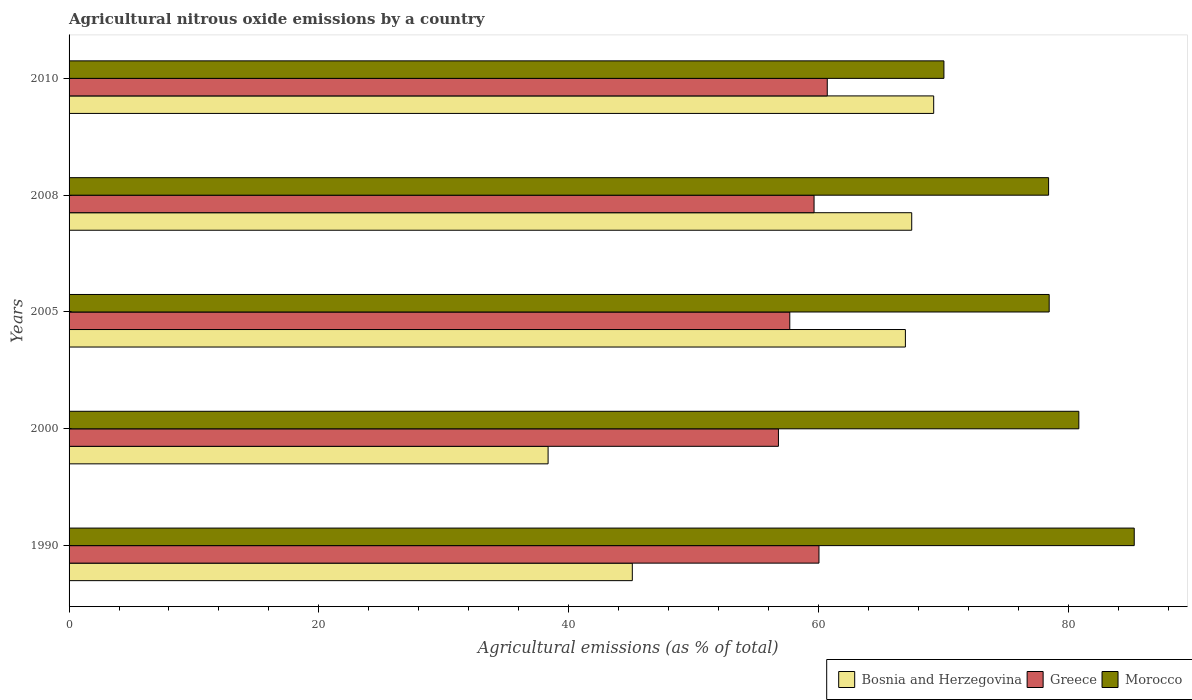How many different coloured bars are there?
Give a very brief answer. 3. Are the number of bars on each tick of the Y-axis equal?
Your response must be concise. Yes. How many bars are there on the 2nd tick from the bottom?
Your answer should be compact. 3. What is the label of the 5th group of bars from the top?
Your answer should be very brief. 1990. In how many cases, is the number of bars for a given year not equal to the number of legend labels?
Your response must be concise. 0. What is the amount of agricultural nitrous oxide emitted in Greece in 2008?
Your answer should be very brief. 59.65. Across all years, what is the maximum amount of agricultural nitrous oxide emitted in Morocco?
Make the answer very short. 85.29. Across all years, what is the minimum amount of agricultural nitrous oxide emitted in Morocco?
Offer a very short reply. 70.05. What is the total amount of agricultural nitrous oxide emitted in Bosnia and Herzegovina in the graph?
Your answer should be compact. 287.13. What is the difference between the amount of agricultural nitrous oxide emitted in Bosnia and Herzegovina in 2000 and that in 2010?
Provide a short and direct response. -30.88. What is the difference between the amount of agricultural nitrous oxide emitted in Bosnia and Herzegovina in 1990 and the amount of agricultural nitrous oxide emitted in Morocco in 2010?
Ensure brevity in your answer.  -24.95. What is the average amount of agricultural nitrous oxide emitted in Greece per year?
Ensure brevity in your answer.  58.98. In the year 2000, what is the difference between the amount of agricultural nitrous oxide emitted in Greece and amount of agricultural nitrous oxide emitted in Bosnia and Herzegovina?
Your response must be concise. 18.44. What is the ratio of the amount of agricultural nitrous oxide emitted in Greece in 2005 to that in 2010?
Provide a short and direct response. 0.95. Is the amount of agricultural nitrous oxide emitted in Greece in 2000 less than that in 2008?
Your answer should be very brief. Yes. Is the difference between the amount of agricultural nitrous oxide emitted in Greece in 2008 and 2010 greater than the difference between the amount of agricultural nitrous oxide emitted in Bosnia and Herzegovina in 2008 and 2010?
Give a very brief answer. Yes. What is the difference between the highest and the second highest amount of agricultural nitrous oxide emitted in Bosnia and Herzegovina?
Your response must be concise. 1.76. What is the difference between the highest and the lowest amount of agricultural nitrous oxide emitted in Bosnia and Herzegovina?
Your answer should be very brief. 30.88. Is the sum of the amount of agricultural nitrous oxide emitted in Bosnia and Herzegovina in 2008 and 2010 greater than the maximum amount of agricultural nitrous oxide emitted in Morocco across all years?
Your answer should be very brief. Yes. What does the 2nd bar from the top in 2010 represents?
Your answer should be very brief. Greece. What does the 3rd bar from the bottom in 2005 represents?
Offer a terse response. Morocco. Is it the case that in every year, the sum of the amount of agricultural nitrous oxide emitted in Morocco and amount of agricultural nitrous oxide emitted in Bosnia and Herzegovina is greater than the amount of agricultural nitrous oxide emitted in Greece?
Your answer should be very brief. Yes. How many bars are there?
Provide a succinct answer. 15. Are all the bars in the graph horizontal?
Provide a short and direct response. Yes. What is the difference between two consecutive major ticks on the X-axis?
Keep it short and to the point. 20. Are the values on the major ticks of X-axis written in scientific E-notation?
Make the answer very short. No. Does the graph contain any zero values?
Offer a terse response. No. Does the graph contain grids?
Provide a succinct answer. No. What is the title of the graph?
Give a very brief answer. Agricultural nitrous oxide emissions by a country. What is the label or title of the X-axis?
Provide a short and direct response. Agricultural emissions (as % of total). What is the label or title of the Y-axis?
Your answer should be very brief. Years. What is the Agricultural emissions (as % of total) in Bosnia and Herzegovina in 1990?
Your response must be concise. 45.1. What is the Agricultural emissions (as % of total) of Greece in 1990?
Ensure brevity in your answer.  60.05. What is the Agricultural emissions (as % of total) of Morocco in 1990?
Ensure brevity in your answer.  85.29. What is the Agricultural emissions (as % of total) in Bosnia and Herzegovina in 2000?
Give a very brief answer. 38.36. What is the Agricultural emissions (as % of total) in Greece in 2000?
Give a very brief answer. 56.8. What is the Agricultural emissions (as % of total) of Morocco in 2000?
Ensure brevity in your answer.  80.86. What is the Agricultural emissions (as % of total) of Bosnia and Herzegovina in 2005?
Keep it short and to the point. 66.97. What is the Agricultural emissions (as % of total) in Greece in 2005?
Your answer should be compact. 57.71. What is the Agricultural emissions (as % of total) in Morocco in 2005?
Give a very brief answer. 78.48. What is the Agricultural emissions (as % of total) of Bosnia and Herzegovina in 2008?
Keep it short and to the point. 67.47. What is the Agricultural emissions (as % of total) in Greece in 2008?
Provide a short and direct response. 59.65. What is the Agricultural emissions (as % of total) of Morocco in 2008?
Give a very brief answer. 78.43. What is the Agricultural emissions (as % of total) in Bosnia and Herzegovina in 2010?
Your answer should be compact. 69.23. What is the Agricultural emissions (as % of total) of Greece in 2010?
Keep it short and to the point. 60.71. What is the Agricultural emissions (as % of total) of Morocco in 2010?
Your answer should be compact. 70.05. Across all years, what is the maximum Agricultural emissions (as % of total) in Bosnia and Herzegovina?
Your response must be concise. 69.23. Across all years, what is the maximum Agricultural emissions (as % of total) in Greece?
Give a very brief answer. 60.71. Across all years, what is the maximum Agricultural emissions (as % of total) of Morocco?
Make the answer very short. 85.29. Across all years, what is the minimum Agricultural emissions (as % of total) in Bosnia and Herzegovina?
Your response must be concise. 38.36. Across all years, what is the minimum Agricultural emissions (as % of total) of Greece?
Your answer should be very brief. 56.8. Across all years, what is the minimum Agricultural emissions (as % of total) of Morocco?
Your response must be concise. 70.05. What is the total Agricultural emissions (as % of total) in Bosnia and Herzegovina in the graph?
Keep it short and to the point. 287.13. What is the total Agricultural emissions (as % of total) in Greece in the graph?
Make the answer very short. 294.92. What is the total Agricultural emissions (as % of total) in Morocco in the graph?
Your response must be concise. 393.11. What is the difference between the Agricultural emissions (as % of total) in Bosnia and Herzegovina in 1990 and that in 2000?
Offer a terse response. 6.74. What is the difference between the Agricultural emissions (as % of total) of Greece in 1990 and that in 2000?
Ensure brevity in your answer.  3.24. What is the difference between the Agricultural emissions (as % of total) of Morocco in 1990 and that in 2000?
Keep it short and to the point. 4.44. What is the difference between the Agricultural emissions (as % of total) in Bosnia and Herzegovina in 1990 and that in 2005?
Offer a very short reply. -21.87. What is the difference between the Agricultural emissions (as % of total) in Greece in 1990 and that in 2005?
Offer a terse response. 2.34. What is the difference between the Agricultural emissions (as % of total) of Morocco in 1990 and that in 2005?
Keep it short and to the point. 6.81. What is the difference between the Agricultural emissions (as % of total) of Bosnia and Herzegovina in 1990 and that in 2008?
Give a very brief answer. -22.37. What is the difference between the Agricultural emissions (as % of total) of Greece in 1990 and that in 2008?
Make the answer very short. 0.39. What is the difference between the Agricultural emissions (as % of total) of Morocco in 1990 and that in 2008?
Offer a very short reply. 6.86. What is the difference between the Agricultural emissions (as % of total) of Bosnia and Herzegovina in 1990 and that in 2010?
Offer a very short reply. -24.13. What is the difference between the Agricultural emissions (as % of total) in Greece in 1990 and that in 2010?
Ensure brevity in your answer.  -0.67. What is the difference between the Agricultural emissions (as % of total) in Morocco in 1990 and that in 2010?
Ensure brevity in your answer.  15.24. What is the difference between the Agricultural emissions (as % of total) in Bosnia and Herzegovina in 2000 and that in 2005?
Keep it short and to the point. -28.61. What is the difference between the Agricultural emissions (as % of total) in Greece in 2000 and that in 2005?
Provide a short and direct response. -0.91. What is the difference between the Agricultural emissions (as % of total) in Morocco in 2000 and that in 2005?
Offer a terse response. 2.37. What is the difference between the Agricultural emissions (as % of total) of Bosnia and Herzegovina in 2000 and that in 2008?
Make the answer very short. -29.12. What is the difference between the Agricultural emissions (as % of total) of Greece in 2000 and that in 2008?
Your answer should be very brief. -2.85. What is the difference between the Agricultural emissions (as % of total) in Morocco in 2000 and that in 2008?
Your answer should be compact. 2.42. What is the difference between the Agricultural emissions (as % of total) in Bosnia and Herzegovina in 2000 and that in 2010?
Your response must be concise. -30.88. What is the difference between the Agricultural emissions (as % of total) in Greece in 2000 and that in 2010?
Ensure brevity in your answer.  -3.91. What is the difference between the Agricultural emissions (as % of total) of Morocco in 2000 and that in 2010?
Your answer should be compact. 10.8. What is the difference between the Agricultural emissions (as % of total) of Bosnia and Herzegovina in 2005 and that in 2008?
Make the answer very short. -0.51. What is the difference between the Agricultural emissions (as % of total) of Greece in 2005 and that in 2008?
Your answer should be compact. -1.94. What is the difference between the Agricultural emissions (as % of total) of Morocco in 2005 and that in 2008?
Offer a very short reply. 0.05. What is the difference between the Agricultural emissions (as % of total) of Bosnia and Herzegovina in 2005 and that in 2010?
Provide a succinct answer. -2.27. What is the difference between the Agricultural emissions (as % of total) in Greece in 2005 and that in 2010?
Make the answer very short. -3. What is the difference between the Agricultural emissions (as % of total) in Morocco in 2005 and that in 2010?
Your answer should be very brief. 8.43. What is the difference between the Agricultural emissions (as % of total) of Bosnia and Herzegovina in 2008 and that in 2010?
Keep it short and to the point. -1.76. What is the difference between the Agricultural emissions (as % of total) of Greece in 2008 and that in 2010?
Make the answer very short. -1.06. What is the difference between the Agricultural emissions (as % of total) in Morocco in 2008 and that in 2010?
Make the answer very short. 8.38. What is the difference between the Agricultural emissions (as % of total) of Bosnia and Herzegovina in 1990 and the Agricultural emissions (as % of total) of Greece in 2000?
Your answer should be compact. -11.7. What is the difference between the Agricultural emissions (as % of total) of Bosnia and Herzegovina in 1990 and the Agricultural emissions (as % of total) of Morocco in 2000?
Offer a terse response. -35.75. What is the difference between the Agricultural emissions (as % of total) of Greece in 1990 and the Agricultural emissions (as % of total) of Morocco in 2000?
Ensure brevity in your answer.  -20.81. What is the difference between the Agricultural emissions (as % of total) of Bosnia and Herzegovina in 1990 and the Agricultural emissions (as % of total) of Greece in 2005?
Provide a succinct answer. -12.61. What is the difference between the Agricultural emissions (as % of total) of Bosnia and Herzegovina in 1990 and the Agricultural emissions (as % of total) of Morocco in 2005?
Make the answer very short. -33.38. What is the difference between the Agricultural emissions (as % of total) in Greece in 1990 and the Agricultural emissions (as % of total) in Morocco in 2005?
Provide a succinct answer. -18.43. What is the difference between the Agricultural emissions (as % of total) of Bosnia and Herzegovina in 1990 and the Agricultural emissions (as % of total) of Greece in 2008?
Make the answer very short. -14.55. What is the difference between the Agricultural emissions (as % of total) of Bosnia and Herzegovina in 1990 and the Agricultural emissions (as % of total) of Morocco in 2008?
Your answer should be very brief. -33.33. What is the difference between the Agricultural emissions (as % of total) in Greece in 1990 and the Agricultural emissions (as % of total) in Morocco in 2008?
Make the answer very short. -18.39. What is the difference between the Agricultural emissions (as % of total) of Bosnia and Herzegovina in 1990 and the Agricultural emissions (as % of total) of Greece in 2010?
Your answer should be compact. -15.61. What is the difference between the Agricultural emissions (as % of total) of Bosnia and Herzegovina in 1990 and the Agricultural emissions (as % of total) of Morocco in 2010?
Your response must be concise. -24.95. What is the difference between the Agricultural emissions (as % of total) of Greece in 1990 and the Agricultural emissions (as % of total) of Morocco in 2010?
Your answer should be very brief. -10.01. What is the difference between the Agricultural emissions (as % of total) of Bosnia and Herzegovina in 2000 and the Agricultural emissions (as % of total) of Greece in 2005?
Your response must be concise. -19.35. What is the difference between the Agricultural emissions (as % of total) of Bosnia and Herzegovina in 2000 and the Agricultural emissions (as % of total) of Morocco in 2005?
Keep it short and to the point. -40.12. What is the difference between the Agricultural emissions (as % of total) of Greece in 2000 and the Agricultural emissions (as % of total) of Morocco in 2005?
Your answer should be compact. -21.68. What is the difference between the Agricultural emissions (as % of total) in Bosnia and Herzegovina in 2000 and the Agricultural emissions (as % of total) in Greece in 2008?
Give a very brief answer. -21.3. What is the difference between the Agricultural emissions (as % of total) in Bosnia and Herzegovina in 2000 and the Agricultural emissions (as % of total) in Morocco in 2008?
Provide a short and direct response. -40.08. What is the difference between the Agricultural emissions (as % of total) in Greece in 2000 and the Agricultural emissions (as % of total) in Morocco in 2008?
Your response must be concise. -21.63. What is the difference between the Agricultural emissions (as % of total) in Bosnia and Herzegovina in 2000 and the Agricultural emissions (as % of total) in Greece in 2010?
Keep it short and to the point. -22.35. What is the difference between the Agricultural emissions (as % of total) in Bosnia and Herzegovina in 2000 and the Agricultural emissions (as % of total) in Morocco in 2010?
Keep it short and to the point. -31.69. What is the difference between the Agricultural emissions (as % of total) in Greece in 2000 and the Agricultural emissions (as % of total) in Morocco in 2010?
Keep it short and to the point. -13.25. What is the difference between the Agricultural emissions (as % of total) of Bosnia and Herzegovina in 2005 and the Agricultural emissions (as % of total) of Greece in 2008?
Your answer should be very brief. 7.31. What is the difference between the Agricultural emissions (as % of total) of Bosnia and Herzegovina in 2005 and the Agricultural emissions (as % of total) of Morocco in 2008?
Offer a terse response. -11.47. What is the difference between the Agricultural emissions (as % of total) of Greece in 2005 and the Agricultural emissions (as % of total) of Morocco in 2008?
Keep it short and to the point. -20.72. What is the difference between the Agricultural emissions (as % of total) in Bosnia and Herzegovina in 2005 and the Agricultural emissions (as % of total) in Greece in 2010?
Provide a succinct answer. 6.26. What is the difference between the Agricultural emissions (as % of total) of Bosnia and Herzegovina in 2005 and the Agricultural emissions (as % of total) of Morocco in 2010?
Your response must be concise. -3.08. What is the difference between the Agricultural emissions (as % of total) of Greece in 2005 and the Agricultural emissions (as % of total) of Morocco in 2010?
Ensure brevity in your answer.  -12.34. What is the difference between the Agricultural emissions (as % of total) of Bosnia and Herzegovina in 2008 and the Agricultural emissions (as % of total) of Greece in 2010?
Offer a very short reply. 6.76. What is the difference between the Agricultural emissions (as % of total) in Bosnia and Herzegovina in 2008 and the Agricultural emissions (as % of total) in Morocco in 2010?
Provide a succinct answer. -2.58. What is the difference between the Agricultural emissions (as % of total) in Greece in 2008 and the Agricultural emissions (as % of total) in Morocco in 2010?
Offer a terse response. -10.4. What is the average Agricultural emissions (as % of total) of Bosnia and Herzegovina per year?
Provide a succinct answer. 57.43. What is the average Agricultural emissions (as % of total) of Greece per year?
Make the answer very short. 58.98. What is the average Agricultural emissions (as % of total) in Morocco per year?
Your answer should be compact. 78.62. In the year 1990, what is the difference between the Agricultural emissions (as % of total) of Bosnia and Herzegovina and Agricultural emissions (as % of total) of Greece?
Keep it short and to the point. -14.95. In the year 1990, what is the difference between the Agricultural emissions (as % of total) of Bosnia and Herzegovina and Agricultural emissions (as % of total) of Morocco?
Keep it short and to the point. -40.19. In the year 1990, what is the difference between the Agricultural emissions (as % of total) of Greece and Agricultural emissions (as % of total) of Morocco?
Ensure brevity in your answer.  -25.24. In the year 2000, what is the difference between the Agricultural emissions (as % of total) of Bosnia and Herzegovina and Agricultural emissions (as % of total) of Greece?
Offer a terse response. -18.44. In the year 2000, what is the difference between the Agricultural emissions (as % of total) of Bosnia and Herzegovina and Agricultural emissions (as % of total) of Morocco?
Your response must be concise. -42.5. In the year 2000, what is the difference between the Agricultural emissions (as % of total) in Greece and Agricultural emissions (as % of total) in Morocco?
Your response must be concise. -24.05. In the year 2005, what is the difference between the Agricultural emissions (as % of total) in Bosnia and Herzegovina and Agricultural emissions (as % of total) in Greece?
Give a very brief answer. 9.26. In the year 2005, what is the difference between the Agricultural emissions (as % of total) of Bosnia and Herzegovina and Agricultural emissions (as % of total) of Morocco?
Offer a very short reply. -11.51. In the year 2005, what is the difference between the Agricultural emissions (as % of total) of Greece and Agricultural emissions (as % of total) of Morocco?
Your response must be concise. -20.77. In the year 2008, what is the difference between the Agricultural emissions (as % of total) in Bosnia and Herzegovina and Agricultural emissions (as % of total) in Greece?
Your answer should be compact. 7.82. In the year 2008, what is the difference between the Agricultural emissions (as % of total) in Bosnia and Herzegovina and Agricultural emissions (as % of total) in Morocco?
Provide a short and direct response. -10.96. In the year 2008, what is the difference between the Agricultural emissions (as % of total) in Greece and Agricultural emissions (as % of total) in Morocco?
Your response must be concise. -18.78. In the year 2010, what is the difference between the Agricultural emissions (as % of total) of Bosnia and Herzegovina and Agricultural emissions (as % of total) of Greece?
Give a very brief answer. 8.52. In the year 2010, what is the difference between the Agricultural emissions (as % of total) of Bosnia and Herzegovina and Agricultural emissions (as % of total) of Morocco?
Provide a short and direct response. -0.82. In the year 2010, what is the difference between the Agricultural emissions (as % of total) of Greece and Agricultural emissions (as % of total) of Morocco?
Your answer should be compact. -9.34. What is the ratio of the Agricultural emissions (as % of total) in Bosnia and Herzegovina in 1990 to that in 2000?
Give a very brief answer. 1.18. What is the ratio of the Agricultural emissions (as % of total) in Greece in 1990 to that in 2000?
Your response must be concise. 1.06. What is the ratio of the Agricultural emissions (as % of total) of Morocco in 1990 to that in 2000?
Keep it short and to the point. 1.05. What is the ratio of the Agricultural emissions (as % of total) of Bosnia and Herzegovina in 1990 to that in 2005?
Offer a very short reply. 0.67. What is the ratio of the Agricultural emissions (as % of total) of Greece in 1990 to that in 2005?
Offer a very short reply. 1.04. What is the ratio of the Agricultural emissions (as % of total) in Morocco in 1990 to that in 2005?
Your answer should be compact. 1.09. What is the ratio of the Agricultural emissions (as % of total) in Bosnia and Herzegovina in 1990 to that in 2008?
Ensure brevity in your answer.  0.67. What is the ratio of the Agricultural emissions (as % of total) in Greece in 1990 to that in 2008?
Provide a succinct answer. 1.01. What is the ratio of the Agricultural emissions (as % of total) of Morocco in 1990 to that in 2008?
Make the answer very short. 1.09. What is the ratio of the Agricultural emissions (as % of total) of Bosnia and Herzegovina in 1990 to that in 2010?
Keep it short and to the point. 0.65. What is the ratio of the Agricultural emissions (as % of total) of Greece in 1990 to that in 2010?
Your response must be concise. 0.99. What is the ratio of the Agricultural emissions (as % of total) in Morocco in 1990 to that in 2010?
Provide a short and direct response. 1.22. What is the ratio of the Agricultural emissions (as % of total) of Bosnia and Herzegovina in 2000 to that in 2005?
Ensure brevity in your answer.  0.57. What is the ratio of the Agricultural emissions (as % of total) of Greece in 2000 to that in 2005?
Your answer should be very brief. 0.98. What is the ratio of the Agricultural emissions (as % of total) of Morocco in 2000 to that in 2005?
Your answer should be compact. 1.03. What is the ratio of the Agricultural emissions (as % of total) of Bosnia and Herzegovina in 2000 to that in 2008?
Offer a very short reply. 0.57. What is the ratio of the Agricultural emissions (as % of total) of Greece in 2000 to that in 2008?
Ensure brevity in your answer.  0.95. What is the ratio of the Agricultural emissions (as % of total) of Morocco in 2000 to that in 2008?
Keep it short and to the point. 1.03. What is the ratio of the Agricultural emissions (as % of total) in Bosnia and Herzegovina in 2000 to that in 2010?
Keep it short and to the point. 0.55. What is the ratio of the Agricultural emissions (as % of total) in Greece in 2000 to that in 2010?
Provide a short and direct response. 0.94. What is the ratio of the Agricultural emissions (as % of total) of Morocco in 2000 to that in 2010?
Your answer should be compact. 1.15. What is the ratio of the Agricultural emissions (as % of total) in Greece in 2005 to that in 2008?
Provide a short and direct response. 0.97. What is the ratio of the Agricultural emissions (as % of total) of Bosnia and Herzegovina in 2005 to that in 2010?
Provide a succinct answer. 0.97. What is the ratio of the Agricultural emissions (as % of total) of Greece in 2005 to that in 2010?
Your response must be concise. 0.95. What is the ratio of the Agricultural emissions (as % of total) of Morocco in 2005 to that in 2010?
Offer a very short reply. 1.12. What is the ratio of the Agricultural emissions (as % of total) of Bosnia and Herzegovina in 2008 to that in 2010?
Your answer should be compact. 0.97. What is the ratio of the Agricultural emissions (as % of total) of Greece in 2008 to that in 2010?
Offer a very short reply. 0.98. What is the ratio of the Agricultural emissions (as % of total) of Morocco in 2008 to that in 2010?
Give a very brief answer. 1.12. What is the difference between the highest and the second highest Agricultural emissions (as % of total) of Bosnia and Herzegovina?
Your response must be concise. 1.76. What is the difference between the highest and the second highest Agricultural emissions (as % of total) in Greece?
Your response must be concise. 0.67. What is the difference between the highest and the second highest Agricultural emissions (as % of total) of Morocco?
Your answer should be compact. 4.44. What is the difference between the highest and the lowest Agricultural emissions (as % of total) in Bosnia and Herzegovina?
Your response must be concise. 30.88. What is the difference between the highest and the lowest Agricultural emissions (as % of total) of Greece?
Provide a succinct answer. 3.91. What is the difference between the highest and the lowest Agricultural emissions (as % of total) of Morocco?
Offer a terse response. 15.24. 